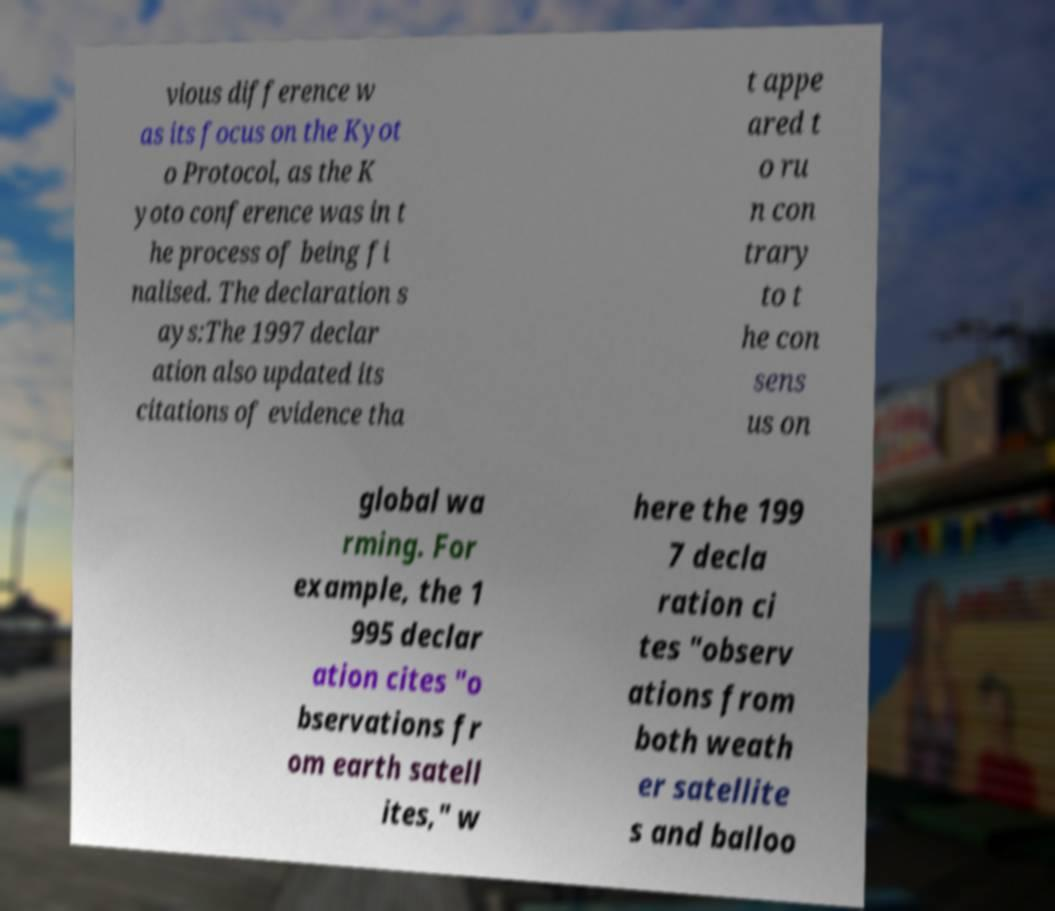Please read and relay the text visible in this image. What does it say? vious difference w as its focus on the Kyot o Protocol, as the K yoto conference was in t he process of being fi nalised. The declaration s ays:The 1997 declar ation also updated its citations of evidence tha t appe ared t o ru n con trary to t he con sens us on global wa rming. For example, the 1 995 declar ation cites "o bservations fr om earth satell ites," w here the 199 7 decla ration ci tes "observ ations from both weath er satellite s and balloo 